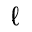Convert formula to latex. <formula><loc_0><loc_0><loc_500><loc_500>\ell</formula> 